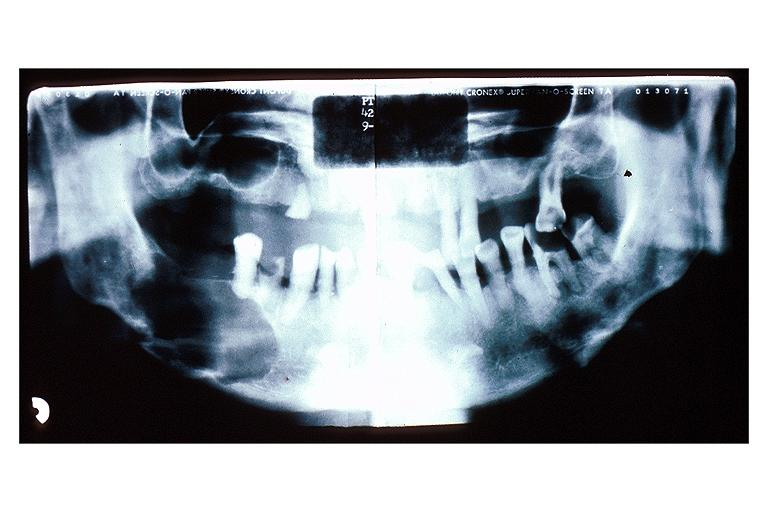what is present?
Answer the question using a single word or phrase. Oral 